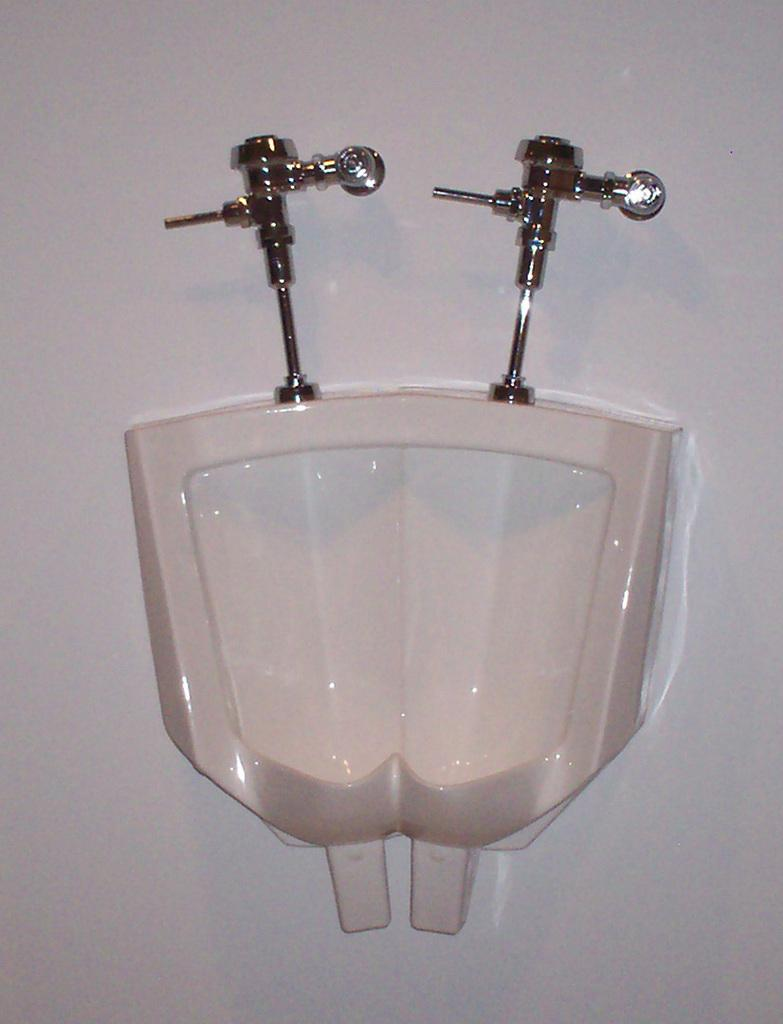What type of fixtures are present in the image? There are urinals and taps in the image. What is the background of the image made of? There is a wall in the image. What type of society is depicted in the image? There is no depiction of a society in the image; it only shows urinals, taps, and a wall. How many bulbs can be seen in the image? There are no bulbs present in the image. 